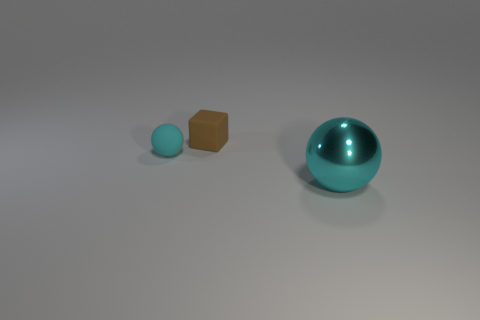Add 2 gray shiny blocks. How many objects exist? 5 Subtract all spheres. How many objects are left? 1 Add 3 cyan matte things. How many cyan matte things are left? 4 Add 3 brown blocks. How many brown blocks exist? 4 Subtract 0 yellow spheres. How many objects are left? 3 Subtract all big cyan blocks. Subtract all brown rubber things. How many objects are left? 2 